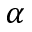Convert formula to latex. <formula><loc_0><loc_0><loc_500><loc_500>\alpha</formula> 